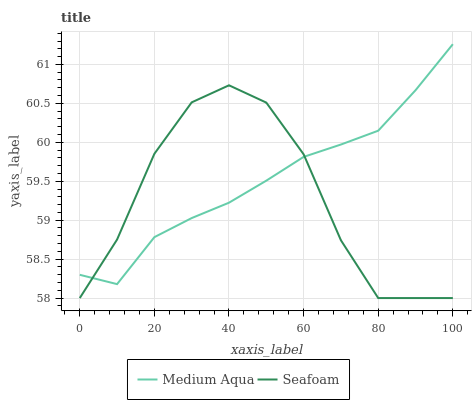Does Seafoam have the minimum area under the curve?
Answer yes or no. Yes. Does Medium Aqua have the maximum area under the curve?
Answer yes or no. Yes. Does Seafoam have the maximum area under the curve?
Answer yes or no. No. Is Medium Aqua the smoothest?
Answer yes or no. Yes. Is Seafoam the roughest?
Answer yes or no. Yes. Is Seafoam the smoothest?
Answer yes or no. No. Does Seafoam have the lowest value?
Answer yes or no. Yes. Does Medium Aqua have the highest value?
Answer yes or no. Yes. Does Seafoam have the highest value?
Answer yes or no. No. Does Medium Aqua intersect Seafoam?
Answer yes or no. Yes. Is Medium Aqua less than Seafoam?
Answer yes or no. No. Is Medium Aqua greater than Seafoam?
Answer yes or no. No. 